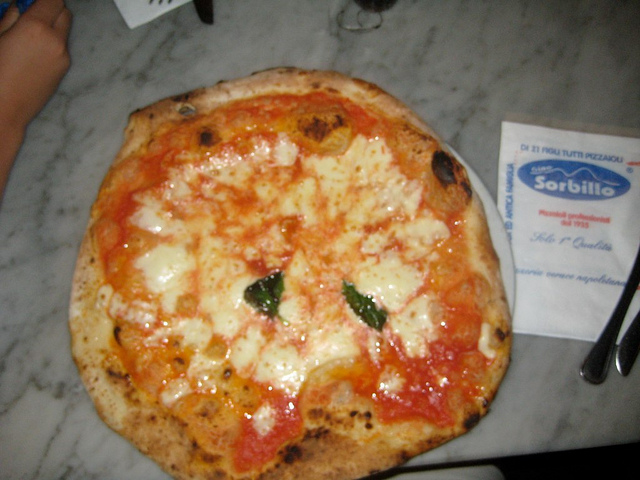<image>What TV show is this food from? I don't know what TV show this food is from. It could be from a range of shows such as 'pizza guy', "that 70's show", 'ninja turtles', 'masterchef', 'chew', 'pizza planet', or '2 guys and pizza place'. How much sauce is on the pizza? It is unknown how much sauce is on the pizza. It can be a little or a lot. Why is the condiment packet taped to the box? It is ambiguous why the condiment packet is taped to the box. Possible reasons could be for safety or to prevent it from getting lost. How much sauce is on the pizza? I don't know how much sauce is on the pizza. It can be seen as a little, small amount, lot or enough. What TV show is this food from? I don't know what TV show this food is from. It could be from 'pizza guy', "that 70's show', 'ninja turtles', 'masterchef', 'chew', 'pizza planet', '2 guys and pizza place' or something else. Why is the condiment packet taped to the box? It is ambiguous why the condiment packet is taped to the box. It could be for safety, to cleanse hands, or to prevent it from dropping or getting lost. 